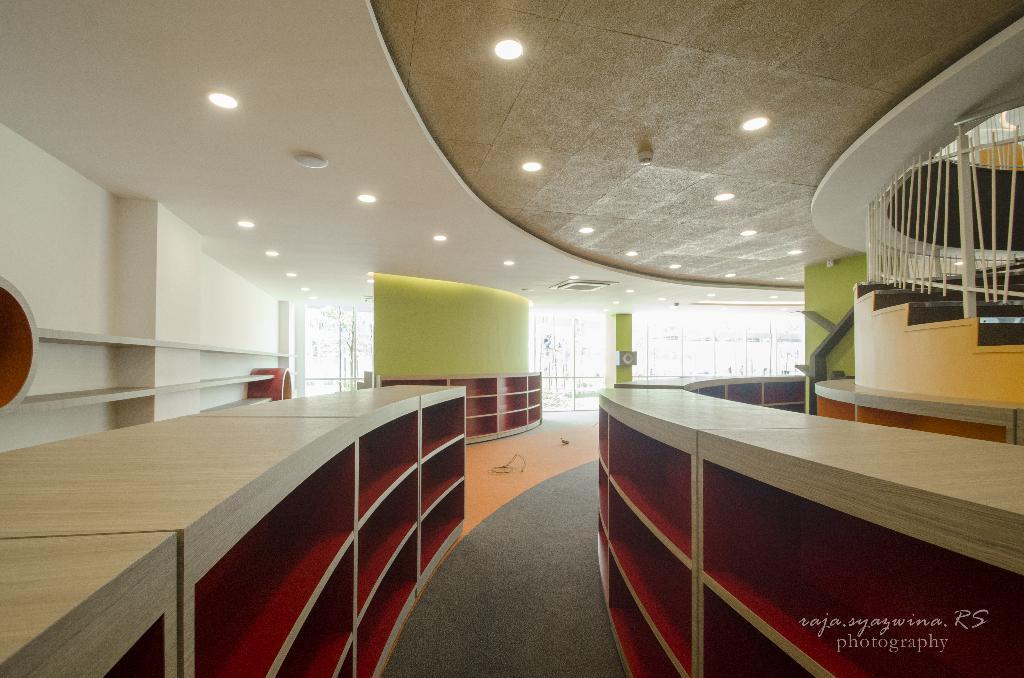Could you give a brief overview of what you see in this image? There are wooden tables present at the bottom of this image. We can see a wall in the background. There are lights attached to the roof as we can see at the top of this image. We can see stairs on the right side of this image. 